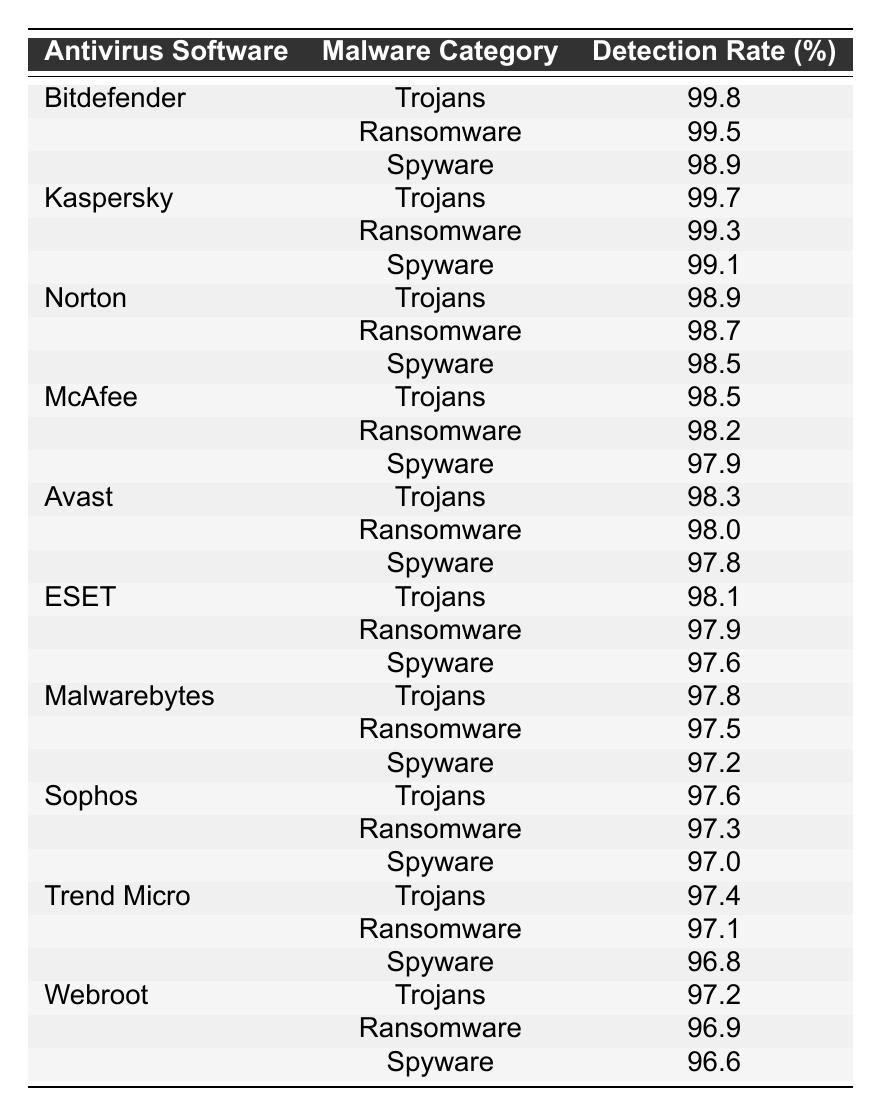What is the detection rate of Bitdefender for Ransomware? The table lists the detection rates by antivirus software and malware category. According to the table, Bitdefender has a detection rate of 99.5% for Ransomware.
Answer: 99.5% Which antivirus software has the highest detection rate for Trojans? By comparing the detection rates for Trojans across all listed antivirus software, Bitdefender shows the highest detection rate at 99.8%.
Answer: Bitdefender What is the detection rate of Norton for Spyware? The table shows that Norton has a detection rate of 98.5% for Spyware.
Answer: 98.5% If we take the average detection rate of Malwarebytes across all categories, what would it be? The detection rates for Malwarebytes are 97.8% (Trojans), 97.5% (Ransomware), and 97.2% (Spyware). Adding them up gives 97.8 + 97.5 + 97.2 = 292.5. Dividing by 3 gives an average of 292.5 / 3 = 97.5%.
Answer: 97.5% Is Kaspersky's detection rate for Spyware higher than that of ESET? The table shows that Kaspersky has a detection rate of 99.1% for Spyware, while ESET has 97.6%. Since 99.1% is higher than 97.6%, Kaspersky's detection rate for Spyware is indeed higher.
Answer: Yes Which two antivirus software have the same detection rate for Trojans? The table reveals that both Norton and McAfee have detection rates of 98.9% for Trojans. They are identical and rank similarly.
Answer: Norton and McAfee What is the difference in detection rates between the highest and lowest ranks for Ransomware? The table shows Bitdefender with 99.5% (highest) and Webroot with 96.9% (lowest) for Ransomware. Calculating the difference, we get 99.5% - 96.9% = 2.6%.
Answer: 2.6% Among the listed antivirus software, which one has the lowest detection rate for Spyware? In checking the Spyware detection rates, Webroot has the lowest detection rate at 96.6%, making it the least effective in this category among the software listed.
Answer: Webroot Are there any antivirus software that achieve a detection rate of 98% or higher for all categories? Based on the table review, both Bitdefender and Kaspersky achieve a detection rate of 98% or higher across Trojans, Ransomware, and Spyware, confirming their top performance in all categories.
Answer: Yes What is the total detection rate for all categories combined for ESET? ESET's detection rates are 98.1% (Trojans), 97.9% (Ransomware), and 97.6% (Spyware). Adding these gives 98.1 + 97.9 + 97.6 = 293.6%. Therefore, ESET's total for all three categories is 293.6%.
Answer: 293.6% 